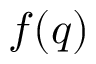<formula> <loc_0><loc_0><loc_500><loc_500>f ( q )</formula> 